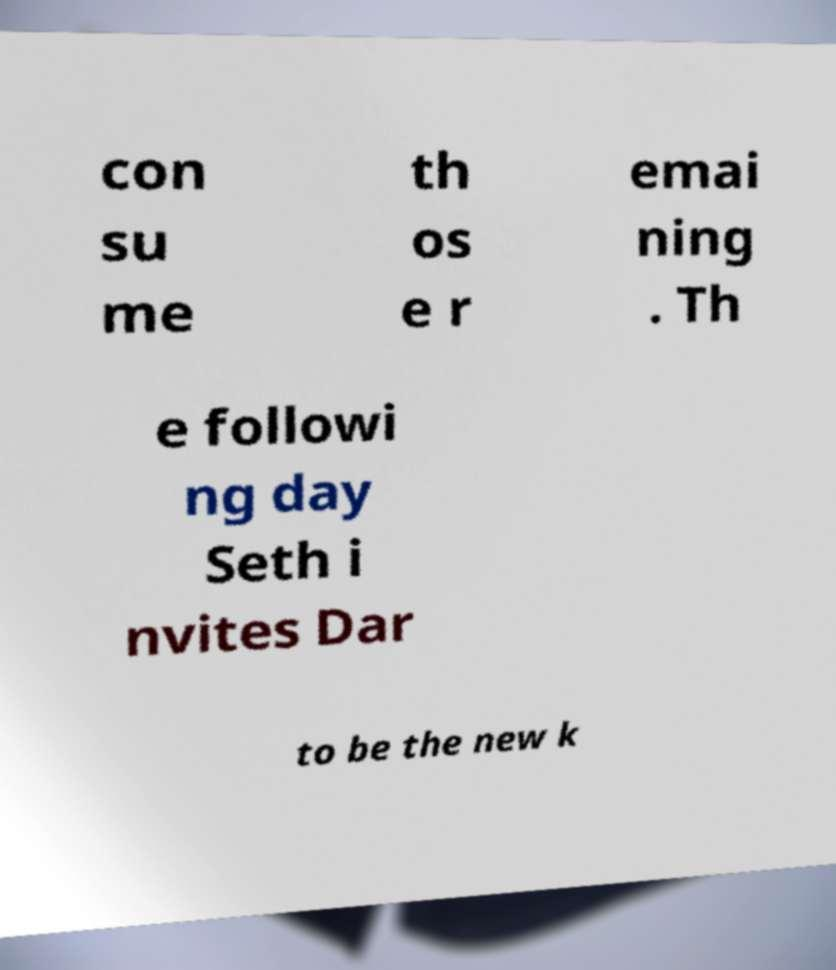Could you extract and type out the text from this image? con su me th os e r emai ning . Th e followi ng day Seth i nvites Dar to be the new k 